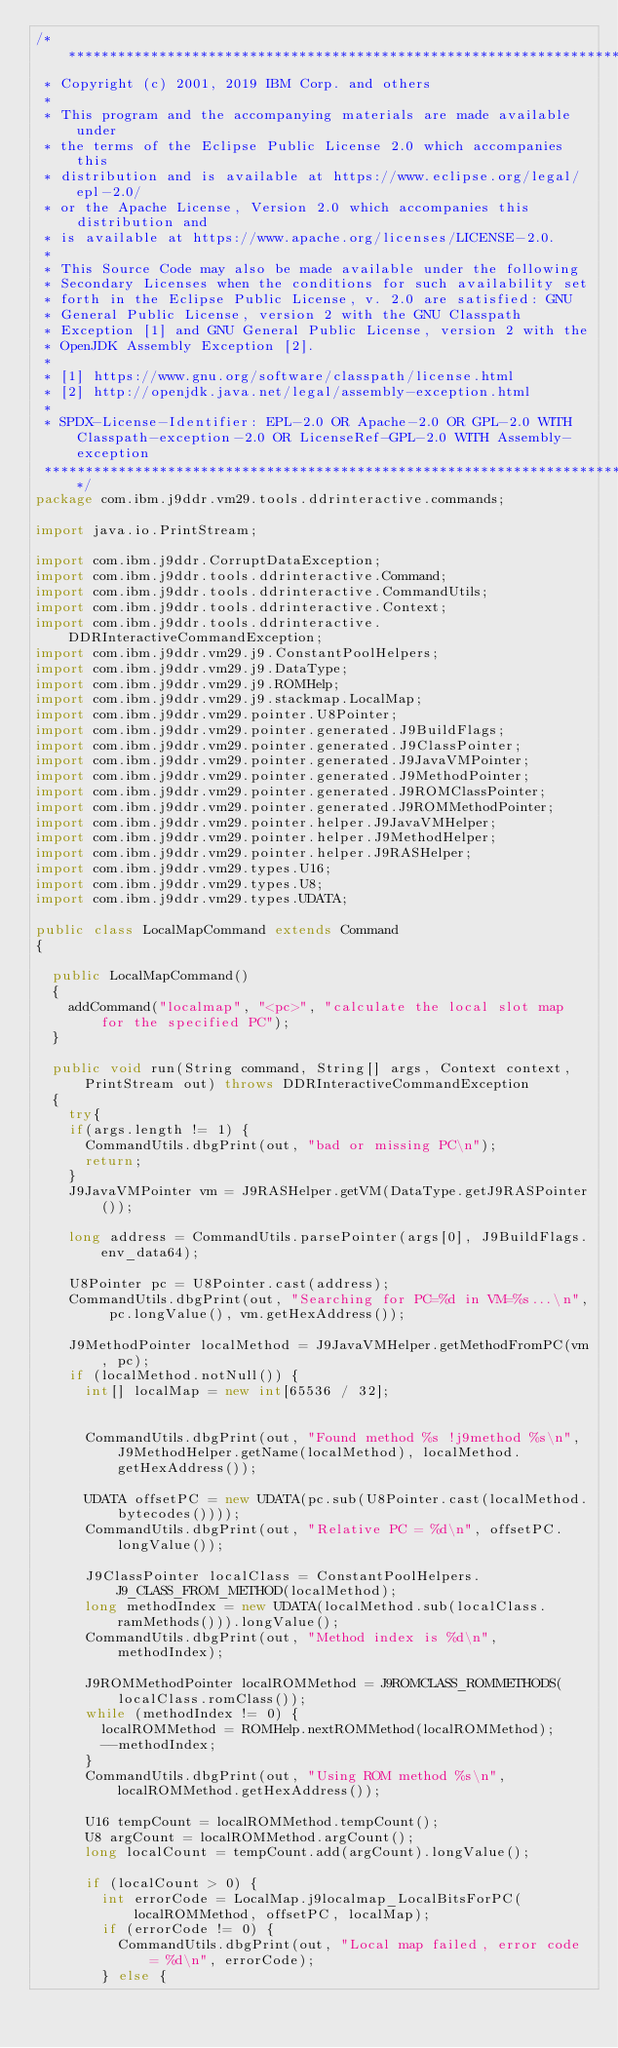<code> <loc_0><loc_0><loc_500><loc_500><_Java_>/*******************************************************************************
 * Copyright (c) 2001, 2019 IBM Corp. and others
 *
 * This program and the accompanying materials are made available under
 * the terms of the Eclipse Public License 2.0 which accompanies this
 * distribution and is available at https://www.eclipse.org/legal/epl-2.0/
 * or the Apache License, Version 2.0 which accompanies this distribution and
 * is available at https://www.apache.org/licenses/LICENSE-2.0.
 *
 * This Source Code may also be made available under the following
 * Secondary Licenses when the conditions for such availability set
 * forth in the Eclipse Public License, v. 2.0 are satisfied: GNU
 * General Public License, version 2 with the GNU Classpath
 * Exception [1] and GNU General Public License, version 2 with the
 * OpenJDK Assembly Exception [2].
 *
 * [1] https://www.gnu.org/software/classpath/license.html
 * [2] http://openjdk.java.net/legal/assembly-exception.html
 *
 * SPDX-License-Identifier: EPL-2.0 OR Apache-2.0 OR GPL-2.0 WITH Classpath-exception-2.0 OR LicenseRef-GPL-2.0 WITH Assembly-exception
 *******************************************************************************/
package com.ibm.j9ddr.vm29.tools.ddrinteractive.commands;

import java.io.PrintStream;

import com.ibm.j9ddr.CorruptDataException;
import com.ibm.j9ddr.tools.ddrinteractive.Command;
import com.ibm.j9ddr.tools.ddrinteractive.CommandUtils;
import com.ibm.j9ddr.tools.ddrinteractive.Context;
import com.ibm.j9ddr.tools.ddrinteractive.DDRInteractiveCommandException;
import com.ibm.j9ddr.vm29.j9.ConstantPoolHelpers;
import com.ibm.j9ddr.vm29.j9.DataType;
import com.ibm.j9ddr.vm29.j9.ROMHelp;
import com.ibm.j9ddr.vm29.j9.stackmap.LocalMap;
import com.ibm.j9ddr.vm29.pointer.U8Pointer;
import com.ibm.j9ddr.vm29.pointer.generated.J9BuildFlags;
import com.ibm.j9ddr.vm29.pointer.generated.J9ClassPointer;
import com.ibm.j9ddr.vm29.pointer.generated.J9JavaVMPointer;
import com.ibm.j9ddr.vm29.pointer.generated.J9MethodPointer;
import com.ibm.j9ddr.vm29.pointer.generated.J9ROMClassPointer;
import com.ibm.j9ddr.vm29.pointer.generated.J9ROMMethodPointer;
import com.ibm.j9ddr.vm29.pointer.helper.J9JavaVMHelper;
import com.ibm.j9ddr.vm29.pointer.helper.J9MethodHelper;
import com.ibm.j9ddr.vm29.pointer.helper.J9RASHelper;
import com.ibm.j9ddr.vm29.types.U16;
import com.ibm.j9ddr.vm29.types.U8;
import com.ibm.j9ddr.vm29.types.UDATA;

public class LocalMapCommand extends Command 
{

	public LocalMapCommand()
	{
		addCommand("localmap", "<pc>", "calculate the local slot map for the specified PC");
	}

	public void run(String command, String[] args, Context context, PrintStream out) throws DDRInteractiveCommandException 
	{
		try{
		if(args.length != 1) {
			CommandUtils.dbgPrint(out, "bad or missing PC\n");
			return;			
		}
		J9JavaVMPointer vm = J9RASHelper.getVM(DataType.getJ9RASPointer());
		
		long address = CommandUtils.parsePointer(args[0], J9BuildFlags.env_data64);
		
		U8Pointer pc = U8Pointer.cast(address);
		CommandUtils.dbgPrint(out, "Searching for PC=%d in VM=%s...\n", pc.longValue(), vm.getHexAddress());

		J9MethodPointer localMethod = J9JavaVMHelper.getMethodFromPC(vm, pc);
		if (localMethod.notNull()) {
			int[] localMap = new int[65536 / 32];
			
		
			CommandUtils.dbgPrint(out, "Found method %s !j9method %s\n", J9MethodHelper.getName(localMethod), localMethod.getHexAddress());

			UDATA offsetPC = new UDATA(pc.sub(U8Pointer.cast(localMethod.bytecodes())));
			CommandUtils.dbgPrint(out, "Relative PC = %d\n", offsetPC.longValue());

			J9ClassPointer localClass = ConstantPoolHelpers.J9_CLASS_FROM_METHOD(localMethod);
			long methodIndex = new UDATA(localMethod.sub(localClass.ramMethods())).longValue();			
			CommandUtils.dbgPrint(out, "Method index is %d\n", methodIndex);
			
			J9ROMMethodPointer localROMMethod = J9ROMCLASS_ROMMETHODS(localClass.romClass());
			while (methodIndex != 0) {
				localROMMethod = ROMHelp.nextROMMethod(localROMMethod);
				--methodIndex;
			}
			CommandUtils.dbgPrint(out, "Using ROM method %s\n", localROMMethod.getHexAddress());
			
			U16 tempCount = localROMMethod.tempCount();
			U8 argCount = localROMMethod.argCount();
			long localCount = tempCount.add(argCount).longValue();

			if (localCount > 0) {
				int errorCode = LocalMap.j9localmap_LocalBitsForPC(localROMMethod, offsetPC, localMap);
				if (errorCode != 0) {
					CommandUtils.dbgPrint(out, "Local map failed, error code = %d\n", errorCode);
				} else {</code> 